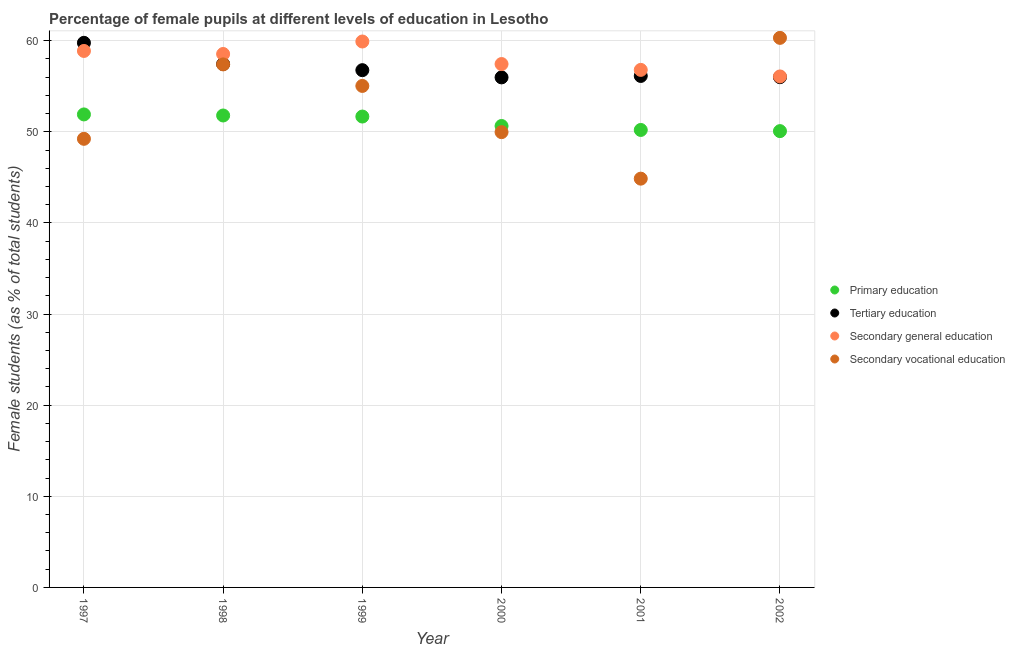How many different coloured dotlines are there?
Provide a short and direct response. 4. Is the number of dotlines equal to the number of legend labels?
Make the answer very short. Yes. What is the percentage of female students in secondary education in 1998?
Give a very brief answer. 58.54. Across all years, what is the maximum percentage of female students in secondary vocational education?
Offer a terse response. 60.31. Across all years, what is the minimum percentage of female students in secondary vocational education?
Your response must be concise. 44.86. In which year was the percentage of female students in secondary vocational education maximum?
Offer a terse response. 2002. What is the total percentage of female students in secondary education in the graph?
Your answer should be very brief. 347.62. What is the difference between the percentage of female students in primary education in 1997 and that in 2002?
Ensure brevity in your answer.  1.83. What is the difference between the percentage of female students in secondary education in 1999 and the percentage of female students in secondary vocational education in 2000?
Provide a short and direct response. 9.95. What is the average percentage of female students in secondary education per year?
Make the answer very short. 57.94. In the year 1998, what is the difference between the percentage of female students in tertiary education and percentage of female students in secondary vocational education?
Give a very brief answer. 0.04. In how many years, is the percentage of female students in secondary education greater than 34 %?
Keep it short and to the point. 6. What is the ratio of the percentage of female students in secondary education in 1999 to that in 2002?
Offer a terse response. 1.07. Is the percentage of female students in secondary vocational education in 1997 less than that in 1998?
Provide a succinct answer. Yes. Is the difference between the percentage of female students in secondary vocational education in 1997 and 2000 greater than the difference between the percentage of female students in secondary education in 1997 and 2000?
Ensure brevity in your answer.  No. What is the difference between the highest and the second highest percentage of female students in secondary education?
Provide a short and direct response. 1.04. What is the difference between the highest and the lowest percentage of female students in secondary education?
Your answer should be compact. 3.83. In how many years, is the percentage of female students in tertiary education greater than the average percentage of female students in tertiary education taken over all years?
Ensure brevity in your answer.  2. Is the sum of the percentage of female students in secondary education in 1997 and 2001 greater than the maximum percentage of female students in primary education across all years?
Ensure brevity in your answer.  Yes. Does the percentage of female students in tertiary education monotonically increase over the years?
Keep it short and to the point. No. Is the percentage of female students in secondary vocational education strictly greater than the percentage of female students in tertiary education over the years?
Offer a very short reply. No. Is the percentage of female students in secondary vocational education strictly less than the percentage of female students in tertiary education over the years?
Provide a succinct answer. No. What is the difference between two consecutive major ticks on the Y-axis?
Your answer should be very brief. 10. Are the values on the major ticks of Y-axis written in scientific E-notation?
Your answer should be very brief. No. Does the graph contain grids?
Keep it short and to the point. Yes. How many legend labels are there?
Provide a short and direct response. 4. How are the legend labels stacked?
Your answer should be very brief. Vertical. What is the title of the graph?
Make the answer very short. Percentage of female pupils at different levels of education in Lesotho. Does "Norway" appear as one of the legend labels in the graph?
Your answer should be very brief. No. What is the label or title of the X-axis?
Provide a succinct answer. Year. What is the label or title of the Y-axis?
Offer a very short reply. Female students (as % of total students). What is the Female students (as % of total students) in Primary education in 1997?
Provide a short and direct response. 51.91. What is the Female students (as % of total students) of Tertiary education in 1997?
Give a very brief answer. 59.76. What is the Female students (as % of total students) of Secondary general education in 1997?
Make the answer very short. 58.87. What is the Female students (as % of total students) in Secondary vocational education in 1997?
Offer a terse response. 49.23. What is the Female students (as % of total students) in Primary education in 1998?
Make the answer very short. 51.79. What is the Female students (as % of total students) in Tertiary education in 1998?
Your answer should be very brief. 57.43. What is the Female students (as % of total students) of Secondary general education in 1998?
Keep it short and to the point. 58.54. What is the Female students (as % of total students) of Secondary vocational education in 1998?
Your answer should be compact. 57.4. What is the Female students (as % of total students) of Primary education in 1999?
Make the answer very short. 51.67. What is the Female students (as % of total students) in Tertiary education in 1999?
Provide a short and direct response. 56.76. What is the Female students (as % of total students) of Secondary general education in 1999?
Offer a terse response. 59.91. What is the Female students (as % of total students) of Secondary vocational education in 1999?
Make the answer very short. 55.03. What is the Female students (as % of total students) of Primary education in 2000?
Give a very brief answer. 50.64. What is the Female students (as % of total students) of Tertiary education in 2000?
Your response must be concise. 55.97. What is the Female students (as % of total students) of Secondary general education in 2000?
Provide a succinct answer. 57.43. What is the Female students (as % of total students) of Secondary vocational education in 2000?
Your response must be concise. 49.96. What is the Female students (as % of total students) in Primary education in 2001?
Give a very brief answer. 50.2. What is the Female students (as % of total students) of Tertiary education in 2001?
Your answer should be very brief. 56.13. What is the Female students (as % of total students) of Secondary general education in 2001?
Offer a very short reply. 56.79. What is the Female students (as % of total students) in Secondary vocational education in 2001?
Give a very brief answer. 44.86. What is the Female students (as % of total students) in Primary education in 2002?
Provide a short and direct response. 50.07. What is the Female students (as % of total students) in Tertiary education in 2002?
Offer a terse response. 55.99. What is the Female students (as % of total students) of Secondary general education in 2002?
Offer a very short reply. 56.07. What is the Female students (as % of total students) of Secondary vocational education in 2002?
Make the answer very short. 60.31. Across all years, what is the maximum Female students (as % of total students) in Primary education?
Your answer should be very brief. 51.91. Across all years, what is the maximum Female students (as % of total students) in Tertiary education?
Keep it short and to the point. 59.76. Across all years, what is the maximum Female students (as % of total students) of Secondary general education?
Your answer should be compact. 59.91. Across all years, what is the maximum Female students (as % of total students) of Secondary vocational education?
Give a very brief answer. 60.31. Across all years, what is the minimum Female students (as % of total students) of Primary education?
Your response must be concise. 50.07. Across all years, what is the minimum Female students (as % of total students) of Tertiary education?
Offer a terse response. 55.97. Across all years, what is the minimum Female students (as % of total students) of Secondary general education?
Ensure brevity in your answer.  56.07. Across all years, what is the minimum Female students (as % of total students) of Secondary vocational education?
Offer a terse response. 44.86. What is the total Female students (as % of total students) of Primary education in the graph?
Provide a succinct answer. 306.28. What is the total Female students (as % of total students) of Tertiary education in the graph?
Your answer should be compact. 342.06. What is the total Female students (as % of total students) in Secondary general education in the graph?
Offer a very short reply. 347.62. What is the total Female students (as % of total students) of Secondary vocational education in the graph?
Offer a very short reply. 316.79. What is the difference between the Female students (as % of total students) in Primary education in 1997 and that in 1998?
Provide a succinct answer. 0.12. What is the difference between the Female students (as % of total students) of Tertiary education in 1997 and that in 1998?
Ensure brevity in your answer.  2.33. What is the difference between the Female students (as % of total students) in Secondary general education in 1997 and that in 1998?
Keep it short and to the point. 0.33. What is the difference between the Female students (as % of total students) in Secondary vocational education in 1997 and that in 1998?
Ensure brevity in your answer.  -8.17. What is the difference between the Female students (as % of total students) of Primary education in 1997 and that in 1999?
Ensure brevity in your answer.  0.23. What is the difference between the Female students (as % of total students) of Tertiary education in 1997 and that in 1999?
Ensure brevity in your answer.  3. What is the difference between the Female students (as % of total students) of Secondary general education in 1997 and that in 1999?
Your answer should be compact. -1.04. What is the difference between the Female students (as % of total students) of Secondary vocational education in 1997 and that in 1999?
Keep it short and to the point. -5.8. What is the difference between the Female students (as % of total students) in Primary education in 1997 and that in 2000?
Provide a short and direct response. 1.27. What is the difference between the Female students (as % of total students) of Tertiary education in 1997 and that in 2000?
Provide a short and direct response. 3.79. What is the difference between the Female students (as % of total students) in Secondary general education in 1997 and that in 2000?
Offer a very short reply. 1.44. What is the difference between the Female students (as % of total students) in Secondary vocational education in 1997 and that in 2000?
Ensure brevity in your answer.  -0.73. What is the difference between the Female students (as % of total students) of Primary education in 1997 and that in 2001?
Provide a short and direct response. 1.7. What is the difference between the Female students (as % of total students) of Tertiary education in 1997 and that in 2001?
Give a very brief answer. 3.64. What is the difference between the Female students (as % of total students) in Secondary general education in 1997 and that in 2001?
Your answer should be very brief. 2.08. What is the difference between the Female students (as % of total students) of Secondary vocational education in 1997 and that in 2001?
Provide a succinct answer. 4.37. What is the difference between the Female students (as % of total students) in Primary education in 1997 and that in 2002?
Give a very brief answer. 1.83. What is the difference between the Female students (as % of total students) of Tertiary education in 1997 and that in 2002?
Offer a terse response. 3.77. What is the difference between the Female students (as % of total students) of Secondary general education in 1997 and that in 2002?
Provide a succinct answer. 2.8. What is the difference between the Female students (as % of total students) of Secondary vocational education in 1997 and that in 2002?
Provide a short and direct response. -11.08. What is the difference between the Female students (as % of total students) of Primary education in 1998 and that in 1999?
Provide a succinct answer. 0.11. What is the difference between the Female students (as % of total students) in Tertiary education in 1998 and that in 1999?
Your answer should be compact. 0.67. What is the difference between the Female students (as % of total students) in Secondary general education in 1998 and that in 1999?
Your response must be concise. -1.37. What is the difference between the Female students (as % of total students) in Secondary vocational education in 1998 and that in 1999?
Your response must be concise. 2.36. What is the difference between the Female students (as % of total students) in Primary education in 1998 and that in 2000?
Keep it short and to the point. 1.15. What is the difference between the Female students (as % of total students) in Tertiary education in 1998 and that in 2000?
Your answer should be very brief. 1.46. What is the difference between the Female students (as % of total students) of Secondary general education in 1998 and that in 2000?
Offer a terse response. 1.1. What is the difference between the Female students (as % of total students) of Secondary vocational education in 1998 and that in 2000?
Offer a very short reply. 7.43. What is the difference between the Female students (as % of total students) of Primary education in 1998 and that in 2001?
Provide a succinct answer. 1.59. What is the difference between the Female students (as % of total students) in Tertiary education in 1998 and that in 2001?
Give a very brief answer. 1.31. What is the difference between the Female students (as % of total students) in Secondary general education in 1998 and that in 2001?
Provide a short and direct response. 1.75. What is the difference between the Female students (as % of total students) in Secondary vocational education in 1998 and that in 2001?
Offer a terse response. 12.54. What is the difference between the Female students (as % of total students) in Primary education in 1998 and that in 2002?
Your response must be concise. 1.72. What is the difference between the Female students (as % of total students) in Tertiary education in 1998 and that in 2002?
Provide a succinct answer. 1.44. What is the difference between the Female students (as % of total students) in Secondary general education in 1998 and that in 2002?
Your answer should be very brief. 2.46. What is the difference between the Female students (as % of total students) in Secondary vocational education in 1998 and that in 2002?
Your response must be concise. -2.91. What is the difference between the Female students (as % of total students) of Primary education in 1999 and that in 2000?
Provide a succinct answer. 1.04. What is the difference between the Female students (as % of total students) of Tertiary education in 1999 and that in 2000?
Your answer should be compact. 0.79. What is the difference between the Female students (as % of total students) of Secondary general education in 1999 and that in 2000?
Offer a very short reply. 2.47. What is the difference between the Female students (as % of total students) of Secondary vocational education in 1999 and that in 2000?
Ensure brevity in your answer.  5.07. What is the difference between the Female students (as % of total students) of Primary education in 1999 and that in 2001?
Keep it short and to the point. 1.47. What is the difference between the Female students (as % of total students) in Tertiary education in 1999 and that in 2001?
Your response must be concise. 0.63. What is the difference between the Female students (as % of total students) in Secondary general education in 1999 and that in 2001?
Make the answer very short. 3.11. What is the difference between the Female students (as % of total students) in Secondary vocational education in 1999 and that in 2001?
Your answer should be very brief. 10.18. What is the difference between the Female students (as % of total students) in Primary education in 1999 and that in 2002?
Provide a short and direct response. 1.6. What is the difference between the Female students (as % of total students) in Tertiary education in 1999 and that in 2002?
Ensure brevity in your answer.  0.77. What is the difference between the Female students (as % of total students) of Secondary general education in 1999 and that in 2002?
Provide a succinct answer. 3.83. What is the difference between the Female students (as % of total students) of Secondary vocational education in 1999 and that in 2002?
Offer a terse response. -5.27. What is the difference between the Female students (as % of total students) in Primary education in 2000 and that in 2001?
Provide a succinct answer. 0.43. What is the difference between the Female students (as % of total students) of Tertiary education in 2000 and that in 2001?
Keep it short and to the point. -0.16. What is the difference between the Female students (as % of total students) of Secondary general education in 2000 and that in 2001?
Ensure brevity in your answer.  0.64. What is the difference between the Female students (as % of total students) in Secondary vocational education in 2000 and that in 2001?
Make the answer very short. 5.1. What is the difference between the Female students (as % of total students) of Primary education in 2000 and that in 2002?
Keep it short and to the point. 0.56. What is the difference between the Female students (as % of total students) in Tertiary education in 2000 and that in 2002?
Offer a very short reply. -0.02. What is the difference between the Female students (as % of total students) of Secondary general education in 2000 and that in 2002?
Offer a very short reply. 1.36. What is the difference between the Female students (as % of total students) of Secondary vocational education in 2000 and that in 2002?
Provide a succinct answer. -10.35. What is the difference between the Female students (as % of total students) in Primary education in 2001 and that in 2002?
Keep it short and to the point. 0.13. What is the difference between the Female students (as % of total students) in Tertiary education in 2001 and that in 2002?
Your answer should be compact. 0.13. What is the difference between the Female students (as % of total students) of Secondary general education in 2001 and that in 2002?
Your answer should be very brief. 0.72. What is the difference between the Female students (as % of total students) in Secondary vocational education in 2001 and that in 2002?
Offer a very short reply. -15.45. What is the difference between the Female students (as % of total students) of Primary education in 1997 and the Female students (as % of total students) of Tertiary education in 1998?
Provide a succinct answer. -5.53. What is the difference between the Female students (as % of total students) of Primary education in 1997 and the Female students (as % of total students) of Secondary general education in 1998?
Ensure brevity in your answer.  -6.63. What is the difference between the Female students (as % of total students) in Primary education in 1997 and the Female students (as % of total students) in Secondary vocational education in 1998?
Offer a very short reply. -5.49. What is the difference between the Female students (as % of total students) of Tertiary education in 1997 and the Female students (as % of total students) of Secondary general education in 1998?
Ensure brevity in your answer.  1.23. What is the difference between the Female students (as % of total students) of Tertiary education in 1997 and the Female students (as % of total students) of Secondary vocational education in 1998?
Provide a succinct answer. 2.37. What is the difference between the Female students (as % of total students) of Secondary general education in 1997 and the Female students (as % of total students) of Secondary vocational education in 1998?
Offer a terse response. 1.48. What is the difference between the Female students (as % of total students) in Primary education in 1997 and the Female students (as % of total students) in Tertiary education in 1999?
Make the answer very short. -4.86. What is the difference between the Female students (as % of total students) of Primary education in 1997 and the Female students (as % of total students) of Secondary general education in 1999?
Your answer should be compact. -8. What is the difference between the Female students (as % of total students) in Primary education in 1997 and the Female students (as % of total students) in Secondary vocational education in 1999?
Offer a very short reply. -3.13. What is the difference between the Female students (as % of total students) of Tertiary education in 1997 and the Female students (as % of total students) of Secondary general education in 1999?
Ensure brevity in your answer.  -0.14. What is the difference between the Female students (as % of total students) in Tertiary education in 1997 and the Female students (as % of total students) in Secondary vocational education in 1999?
Provide a succinct answer. 4.73. What is the difference between the Female students (as % of total students) of Secondary general education in 1997 and the Female students (as % of total students) of Secondary vocational education in 1999?
Offer a terse response. 3.84. What is the difference between the Female students (as % of total students) in Primary education in 1997 and the Female students (as % of total students) in Tertiary education in 2000?
Your answer should be compact. -4.06. What is the difference between the Female students (as % of total students) of Primary education in 1997 and the Female students (as % of total students) of Secondary general education in 2000?
Your answer should be compact. -5.53. What is the difference between the Female students (as % of total students) of Primary education in 1997 and the Female students (as % of total students) of Secondary vocational education in 2000?
Your response must be concise. 1.94. What is the difference between the Female students (as % of total students) in Tertiary education in 1997 and the Female students (as % of total students) in Secondary general education in 2000?
Provide a succinct answer. 2.33. What is the difference between the Female students (as % of total students) of Tertiary education in 1997 and the Female students (as % of total students) of Secondary vocational education in 2000?
Keep it short and to the point. 9.8. What is the difference between the Female students (as % of total students) of Secondary general education in 1997 and the Female students (as % of total students) of Secondary vocational education in 2000?
Offer a terse response. 8.91. What is the difference between the Female students (as % of total students) of Primary education in 1997 and the Female students (as % of total students) of Tertiary education in 2001?
Make the answer very short. -4.22. What is the difference between the Female students (as % of total students) in Primary education in 1997 and the Female students (as % of total students) in Secondary general education in 2001?
Make the answer very short. -4.89. What is the difference between the Female students (as % of total students) of Primary education in 1997 and the Female students (as % of total students) of Secondary vocational education in 2001?
Keep it short and to the point. 7.05. What is the difference between the Female students (as % of total students) in Tertiary education in 1997 and the Female students (as % of total students) in Secondary general education in 2001?
Give a very brief answer. 2.97. What is the difference between the Female students (as % of total students) of Tertiary education in 1997 and the Female students (as % of total students) of Secondary vocational education in 2001?
Your response must be concise. 14.91. What is the difference between the Female students (as % of total students) of Secondary general education in 1997 and the Female students (as % of total students) of Secondary vocational education in 2001?
Your answer should be very brief. 14.01. What is the difference between the Female students (as % of total students) in Primary education in 1997 and the Female students (as % of total students) in Tertiary education in 2002?
Keep it short and to the point. -4.09. What is the difference between the Female students (as % of total students) in Primary education in 1997 and the Female students (as % of total students) in Secondary general education in 2002?
Your response must be concise. -4.17. What is the difference between the Female students (as % of total students) of Primary education in 1997 and the Female students (as % of total students) of Secondary vocational education in 2002?
Make the answer very short. -8.4. What is the difference between the Female students (as % of total students) of Tertiary education in 1997 and the Female students (as % of total students) of Secondary general education in 2002?
Give a very brief answer. 3.69. What is the difference between the Female students (as % of total students) in Tertiary education in 1997 and the Female students (as % of total students) in Secondary vocational education in 2002?
Give a very brief answer. -0.54. What is the difference between the Female students (as % of total students) in Secondary general education in 1997 and the Female students (as % of total students) in Secondary vocational education in 2002?
Offer a very short reply. -1.44. What is the difference between the Female students (as % of total students) in Primary education in 1998 and the Female students (as % of total students) in Tertiary education in 1999?
Provide a succinct answer. -4.97. What is the difference between the Female students (as % of total students) of Primary education in 1998 and the Female students (as % of total students) of Secondary general education in 1999?
Provide a succinct answer. -8.12. What is the difference between the Female students (as % of total students) in Primary education in 1998 and the Female students (as % of total students) in Secondary vocational education in 1999?
Offer a terse response. -3.24. What is the difference between the Female students (as % of total students) in Tertiary education in 1998 and the Female students (as % of total students) in Secondary general education in 1999?
Make the answer very short. -2.47. What is the difference between the Female students (as % of total students) in Tertiary education in 1998 and the Female students (as % of total students) in Secondary vocational education in 1999?
Your answer should be very brief. 2.4. What is the difference between the Female students (as % of total students) of Secondary general education in 1998 and the Female students (as % of total students) of Secondary vocational education in 1999?
Give a very brief answer. 3.51. What is the difference between the Female students (as % of total students) of Primary education in 1998 and the Female students (as % of total students) of Tertiary education in 2000?
Make the answer very short. -4.18. What is the difference between the Female students (as % of total students) in Primary education in 1998 and the Female students (as % of total students) in Secondary general education in 2000?
Make the answer very short. -5.65. What is the difference between the Female students (as % of total students) in Primary education in 1998 and the Female students (as % of total students) in Secondary vocational education in 2000?
Keep it short and to the point. 1.83. What is the difference between the Female students (as % of total students) in Tertiary education in 1998 and the Female students (as % of total students) in Secondary general education in 2000?
Ensure brevity in your answer.  -0. What is the difference between the Female students (as % of total students) in Tertiary education in 1998 and the Female students (as % of total students) in Secondary vocational education in 2000?
Make the answer very short. 7.47. What is the difference between the Female students (as % of total students) of Secondary general education in 1998 and the Female students (as % of total students) of Secondary vocational education in 2000?
Provide a short and direct response. 8.58. What is the difference between the Female students (as % of total students) in Primary education in 1998 and the Female students (as % of total students) in Tertiary education in 2001?
Offer a very short reply. -4.34. What is the difference between the Female students (as % of total students) in Primary education in 1998 and the Female students (as % of total students) in Secondary general education in 2001?
Your response must be concise. -5. What is the difference between the Female students (as % of total students) of Primary education in 1998 and the Female students (as % of total students) of Secondary vocational education in 2001?
Give a very brief answer. 6.93. What is the difference between the Female students (as % of total students) of Tertiary education in 1998 and the Female students (as % of total students) of Secondary general education in 2001?
Give a very brief answer. 0.64. What is the difference between the Female students (as % of total students) in Tertiary education in 1998 and the Female students (as % of total students) in Secondary vocational education in 2001?
Offer a very short reply. 12.58. What is the difference between the Female students (as % of total students) in Secondary general education in 1998 and the Female students (as % of total students) in Secondary vocational education in 2001?
Provide a succinct answer. 13.68. What is the difference between the Female students (as % of total students) in Primary education in 1998 and the Female students (as % of total students) in Tertiary education in 2002?
Offer a very short reply. -4.21. What is the difference between the Female students (as % of total students) in Primary education in 1998 and the Female students (as % of total students) in Secondary general education in 2002?
Your response must be concise. -4.29. What is the difference between the Female students (as % of total students) in Primary education in 1998 and the Female students (as % of total students) in Secondary vocational education in 2002?
Offer a terse response. -8.52. What is the difference between the Female students (as % of total students) of Tertiary education in 1998 and the Female students (as % of total students) of Secondary general education in 2002?
Your answer should be very brief. 1.36. What is the difference between the Female students (as % of total students) in Tertiary education in 1998 and the Female students (as % of total students) in Secondary vocational education in 2002?
Keep it short and to the point. -2.87. What is the difference between the Female students (as % of total students) of Secondary general education in 1998 and the Female students (as % of total students) of Secondary vocational education in 2002?
Ensure brevity in your answer.  -1.77. What is the difference between the Female students (as % of total students) of Primary education in 1999 and the Female students (as % of total students) of Tertiary education in 2000?
Make the answer very short. -4.3. What is the difference between the Female students (as % of total students) in Primary education in 1999 and the Female students (as % of total students) in Secondary general education in 2000?
Make the answer very short. -5.76. What is the difference between the Female students (as % of total students) in Primary education in 1999 and the Female students (as % of total students) in Secondary vocational education in 2000?
Offer a very short reply. 1.71. What is the difference between the Female students (as % of total students) in Tertiary education in 1999 and the Female students (as % of total students) in Secondary general education in 2000?
Your response must be concise. -0.67. What is the difference between the Female students (as % of total students) in Tertiary education in 1999 and the Female students (as % of total students) in Secondary vocational education in 2000?
Ensure brevity in your answer.  6.8. What is the difference between the Female students (as % of total students) in Secondary general education in 1999 and the Female students (as % of total students) in Secondary vocational education in 2000?
Give a very brief answer. 9.95. What is the difference between the Female students (as % of total students) of Primary education in 1999 and the Female students (as % of total students) of Tertiary education in 2001?
Offer a terse response. -4.45. What is the difference between the Female students (as % of total students) of Primary education in 1999 and the Female students (as % of total students) of Secondary general education in 2001?
Your response must be concise. -5.12. What is the difference between the Female students (as % of total students) of Primary education in 1999 and the Female students (as % of total students) of Secondary vocational education in 2001?
Provide a succinct answer. 6.82. What is the difference between the Female students (as % of total students) in Tertiary education in 1999 and the Female students (as % of total students) in Secondary general education in 2001?
Ensure brevity in your answer.  -0.03. What is the difference between the Female students (as % of total students) in Tertiary education in 1999 and the Female students (as % of total students) in Secondary vocational education in 2001?
Your answer should be compact. 11.9. What is the difference between the Female students (as % of total students) of Secondary general education in 1999 and the Female students (as % of total students) of Secondary vocational education in 2001?
Provide a short and direct response. 15.05. What is the difference between the Female students (as % of total students) in Primary education in 1999 and the Female students (as % of total students) in Tertiary education in 2002?
Provide a short and direct response. -4.32. What is the difference between the Female students (as % of total students) of Primary education in 1999 and the Female students (as % of total students) of Secondary general education in 2002?
Ensure brevity in your answer.  -4.4. What is the difference between the Female students (as % of total students) in Primary education in 1999 and the Female students (as % of total students) in Secondary vocational education in 2002?
Provide a succinct answer. -8.63. What is the difference between the Female students (as % of total students) of Tertiary education in 1999 and the Female students (as % of total students) of Secondary general education in 2002?
Your response must be concise. 0.69. What is the difference between the Female students (as % of total students) of Tertiary education in 1999 and the Female students (as % of total students) of Secondary vocational education in 2002?
Ensure brevity in your answer.  -3.55. What is the difference between the Female students (as % of total students) in Secondary general education in 1999 and the Female students (as % of total students) in Secondary vocational education in 2002?
Offer a very short reply. -0.4. What is the difference between the Female students (as % of total students) in Primary education in 2000 and the Female students (as % of total students) in Tertiary education in 2001?
Offer a very short reply. -5.49. What is the difference between the Female students (as % of total students) of Primary education in 2000 and the Female students (as % of total students) of Secondary general education in 2001?
Your answer should be compact. -6.16. What is the difference between the Female students (as % of total students) in Primary education in 2000 and the Female students (as % of total students) in Secondary vocational education in 2001?
Provide a succinct answer. 5.78. What is the difference between the Female students (as % of total students) of Tertiary education in 2000 and the Female students (as % of total students) of Secondary general education in 2001?
Make the answer very short. -0.82. What is the difference between the Female students (as % of total students) in Tertiary education in 2000 and the Female students (as % of total students) in Secondary vocational education in 2001?
Give a very brief answer. 11.11. What is the difference between the Female students (as % of total students) in Secondary general education in 2000 and the Female students (as % of total students) in Secondary vocational education in 2001?
Give a very brief answer. 12.58. What is the difference between the Female students (as % of total students) in Primary education in 2000 and the Female students (as % of total students) in Tertiary education in 2002?
Your answer should be compact. -5.36. What is the difference between the Female students (as % of total students) in Primary education in 2000 and the Female students (as % of total students) in Secondary general education in 2002?
Make the answer very short. -5.44. What is the difference between the Female students (as % of total students) of Primary education in 2000 and the Female students (as % of total students) of Secondary vocational education in 2002?
Provide a short and direct response. -9.67. What is the difference between the Female students (as % of total students) in Tertiary education in 2000 and the Female students (as % of total students) in Secondary general education in 2002?
Your answer should be very brief. -0.1. What is the difference between the Female students (as % of total students) of Tertiary education in 2000 and the Female students (as % of total students) of Secondary vocational education in 2002?
Your response must be concise. -4.34. What is the difference between the Female students (as % of total students) of Secondary general education in 2000 and the Female students (as % of total students) of Secondary vocational education in 2002?
Your answer should be compact. -2.87. What is the difference between the Female students (as % of total students) of Primary education in 2001 and the Female students (as % of total students) of Tertiary education in 2002?
Make the answer very short. -5.79. What is the difference between the Female students (as % of total students) of Primary education in 2001 and the Female students (as % of total students) of Secondary general education in 2002?
Offer a terse response. -5.87. What is the difference between the Female students (as % of total students) of Primary education in 2001 and the Female students (as % of total students) of Secondary vocational education in 2002?
Your answer should be very brief. -10.11. What is the difference between the Female students (as % of total students) in Tertiary education in 2001 and the Female students (as % of total students) in Secondary general education in 2002?
Make the answer very short. 0.05. What is the difference between the Female students (as % of total students) in Tertiary education in 2001 and the Female students (as % of total students) in Secondary vocational education in 2002?
Provide a succinct answer. -4.18. What is the difference between the Female students (as % of total students) of Secondary general education in 2001 and the Female students (as % of total students) of Secondary vocational education in 2002?
Your answer should be very brief. -3.51. What is the average Female students (as % of total students) in Primary education per year?
Provide a short and direct response. 51.05. What is the average Female students (as % of total students) of Tertiary education per year?
Provide a short and direct response. 57.01. What is the average Female students (as % of total students) in Secondary general education per year?
Ensure brevity in your answer.  57.94. What is the average Female students (as % of total students) in Secondary vocational education per year?
Keep it short and to the point. 52.8. In the year 1997, what is the difference between the Female students (as % of total students) of Primary education and Female students (as % of total students) of Tertiary education?
Your response must be concise. -7.86. In the year 1997, what is the difference between the Female students (as % of total students) of Primary education and Female students (as % of total students) of Secondary general education?
Give a very brief answer. -6.97. In the year 1997, what is the difference between the Female students (as % of total students) of Primary education and Female students (as % of total students) of Secondary vocational education?
Your answer should be very brief. 2.68. In the year 1997, what is the difference between the Female students (as % of total students) of Tertiary education and Female students (as % of total students) of Secondary general education?
Provide a short and direct response. 0.89. In the year 1997, what is the difference between the Female students (as % of total students) of Tertiary education and Female students (as % of total students) of Secondary vocational education?
Your answer should be compact. 10.54. In the year 1997, what is the difference between the Female students (as % of total students) of Secondary general education and Female students (as % of total students) of Secondary vocational education?
Your response must be concise. 9.64. In the year 1998, what is the difference between the Female students (as % of total students) of Primary education and Female students (as % of total students) of Tertiary education?
Offer a very short reply. -5.64. In the year 1998, what is the difference between the Female students (as % of total students) of Primary education and Female students (as % of total students) of Secondary general education?
Keep it short and to the point. -6.75. In the year 1998, what is the difference between the Female students (as % of total students) in Primary education and Female students (as % of total students) in Secondary vocational education?
Offer a very short reply. -5.61. In the year 1998, what is the difference between the Female students (as % of total students) of Tertiary education and Female students (as % of total students) of Secondary general education?
Ensure brevity in your answer.  -1.11. In the year 1998, what is the difference between the Female students (as % of total students) of Tertiary education and Female students (as % of total students) of Secondary vocational education?
Keep it short and to the point. 0.04. In the year 1998, what is the difference between the Female students (as % of total students) in Secondary general education and Female students (as % of total students) in Secondary vocational education?
Provide a short and direct response. 1.14. In the year 1999, what is the difference between the Female students (as % of total students) in Primary education and Female students (as % of total students) in Tertiary education?
Keep it short and to the point. -5.09. In the year 1999, what is the difference between the Female students (as % of total students) in Primary education and Female students (as % of total students) in Secondary general education?
Provide a short and direct response. -8.23. In the year 1999, what is the difference between the Female students (as % of total students) of Primary education and Female students (as % of total students) of Secondary vocational education?
Give a very brief answer. -3.36. In the year 1999, what is the difference between the Female students (as % of total students) of Tertiary education and Female students (as % of total students) of Secondary general education?
Your response must be concise. -3.15. In the year 1999, what is the difference between the Female students (as % of total students) in Tertiary education and Female students (as % of total students) in Secondary vocational education?
Your answer should be compact. 1.73. In the year 1999, what is the difference between the Female students (as % of total students) of Secondary general education and Female students (as % of total students) of Secondary vocational education?
Offer a terse response. 4.87. In the year 2000, what is the difference between the Female students (as % of total students) in Primary education and Female students (as % of total students) in Tertiary education?
Keep it short and to the point. -5.33. In the year 2000, what is the difference between the Female students (as % of total students) of Primary education and Female students (as % of total students) of Secondary general education?
Offer a terse response. -6.8. In the year 2000, what is the difference between the Female students (as % of total students) in Primary education and Female students (as % of total students) in Secondary vocational education?
Your answer should be very brief. 0.67. In the year 2000, what is the difference between the Female students (as % of total students) of Tertiary education and Female students (as % of total students) of Secondary general education?
Provide a succinct answer. -1.46. In the year 2000, what is the difference between the Female students (as % of total students) in Tertiary education and Female students (as % of total students) in Secondary vocational education?
Keep it short and to the point. 6.01. In the year 2000, what is the difference between the Female students (as % of total students) in Secondary general education and Female students (as % of total students) in Secondary vocational education?
Your answer should be compact. 7.47. In the year 2001, what is the difference between the Female students (as % of total students) of Primary education and Female students (as % of total students) of Tertiary education?
Your answer should be very brief. -5.93. In the year 2001, what is the difference between the Female students (as % of total students) of Primary education and Female students (as % of total students) of Secondary general education?
Provide a succinct answer. -6.59. In the year 2001, what is the difference between the Female students (as % of total students) in Primary education and Female students (as % of total students) in Secondary vocational education?
Give a very brief answer. 5.34. In the year 2001, what is the difference between the Female students (as % of total students) in Tertiary education and Female students (as % of total students) in Secondary general education?
Make the answer very short. -0.67. In the year 2001, what is the difference between the Female students (as % of total students) in Tertiary education and Female students (as % of total students) in Secondary vocational education?
Offer a very short reply. 11.27. In the year 2001, what is the difference between the Female students (as % of total students) of Secondary general education and Female students (as % of total students) of Secondary vocational education?
Provide a short and direct response. 11.94. In the year 2002, what is the difference between the Female students (as % of total students) of Primary education and Female students (as % of total students) of Tertiary education?
Ensure brevity in your answer.  -5.92. In the year 2002, what is the difference between the Female students (as % of total students) in Primary education and Female students (as % of total students) in Secondary general education?
Give a very brief answer. -6. In the year 2002, what is the difference between the Female students (as % of total students) in Primary education and Female students (as % of total students) in Secondary vocational education?
Offer a very short reply. -10.23. In the year 2002, what is the difference between the Female students (as % of total students) in Tertiary education and Female students (as % of total students) in Secondary general education?
Make the answer very short. -0.08. In the year 2002, what is the difference between the Female students (as % of total students) of Tertiary education and Female students (as % of total students) of Secondary vocational education?
Your answer should be compact. -4.31. In the year 2002, what is the difference between the Female students (as % of total students) in Secondary general education and Female students (as % of total students) in Secondary vocational education?
Ensure brevity in your answer.  -4.23. What is the ratio of the Female students (as % of total students) of Tertiary education in 1997 to that in 1998?
Your answer should be compact. 1.04. What is the ratio of the Female students (as % of total students) of Secondary vocational education in 1997 to that in 1998?
Your answer should be very brief. 0.86. What is the ratio of the Female students (as % of total students) of Primary education in 1997 to that in 1999?
Give a very brief answer. 1. What is the ratio of the Female students (as % of total students) in Tertiary education in 1997 to that in 1999?
Give a very brief answer. 1.05. What is the ratio of the Female students (as % of total students) in Secondary general education in 1997 to that in 1999?
Keep it short and to the point. 0.98. What is the ratio of the Female students (as % of total students) of Secondary vocational education in 1997 to that in 1999?
Your response must be concise. 0.89. What is the ratio of the Female students (as % of total students) in Primary education in 1997 to that in 2000?
Give a very brief answer. 1.03. What is the ratio of the Female students (as % of total students) in Tertiary education in 1997 to that in 2000?
Offer a terse response. 1.07. What is the ratio of the Female students (as % of total students) of Secondary general education in 1997 to that in 2000?
Provide a succinct answer. 1.02. What is the ratio of the Female students (as % of total students) of Primary education in 1997 to that in 2001?
Provide a succinct answer. 1.03. What is the ratio of the Female students (as % of total students) in Tertiary education in 1997 to that in 2001?
Give a very brief answer. 1.06. What is the ratio of the Female students (as % of total students) of Secondary general education in 1997 to that in 2001?
Provide a succinct answer. 1.04. What is the ratio of the Female students (as % of total students) of Secondary vocational education in 1997 to that in 2001?
Your answer should be very brief. 1.1. What is the ratio of the Female students (as % of total students) in Primary education in 1997 to that in 2002?
Your answer should be compact. 1.04. What is the ratio of the Female students (as % of total students) of Tertiary education in 1997 to that in 2002?
Provide a short and direct response. 1.07. What is the ratio of the Female students (as % of total students) of Secondary general education in 1997 to that in 2002?
Make the answer very short. 1.05. What is the ratio of the Female students (as % of total students) in Secondary vocational education in 1997 to that in 2002?
Offer a very short reply. 0.82. What is the ratio of the Female students (as % of total students) of Primary education in 1998 to that in 1999?
Your response must be concise. 1. What is the ratio of the Female students (as % of total students) of Tertiary education in 1998 to that in 1999?
Give a very brief answer. 1.01. What is the ratio of the Female students (as % of total students) of Secondary general education in 1998 to that in 1999?
Make the answer very short. 0.98. What is the ratio of the Female students (as % of total students) of Secondary vocational education in 1998 to that in 1999?
Your answer should be very brief. 1.04. What is the ratio of the Female students (as % of total students) in Primary education in 1998 to that in 2000?
Give a very brief answer. 1.02. What is the ratio of the Female students (as % of total students) of Tertiary education in 1998 to that in 2000?
Offer a terse response. 1.03. What is the ratio of the Female students (as % of total students) in Secondary general education in 1998 to that in 2000?
Offer a very short reply. 1.02. What is the ratio of the Female students (as % of total students) in Secondary vocational education in 1998 to that in 2000?
Your response must be concise. 1.15. What is the ratio of the Female students (as % of total students) in Primary education in 1998 to that in 2001?
Your answer should be very brief. 1.03. What is the ratio of the Female students (as % of total students) in Tertiary education in 1998 to that in 2001?
Your response must be concise. 1.02. What is the ratio of the Female students (as % of total students) in Secondary general education in 1998 to that in 2001?
Make the answer very short. 1.03. What is the ratio of the Female students (as % of total students) in Secondary vocational education in 1998 to that in 2001?
Keep it short and to the point. 1.28. What is the ratio of the Female students (as % of total students) in Primary education in 1998 to that in 2002?
Provide a short and direct response. 1.03. What is the ratio of the Female students (as % of total students) in Tertiary education in 1998 to that in 2002?
Your response must be concise. 1.03. What is the ratio of the Female students (as % of total students) in Secondary general education in 1998 to that in 2002?
Offer a very short reply. 1.04. What is the ratio of the Female students (as % of total students) of Secondary vocational education in 1998 to that in 2002?
Provide a short and direct response. 0.95. What is the ratio of the Female students (as % of total students) in Primary education in 1999 to that in 2000?
Keep it short and to the point. 1.02. What is the ratio of the Female students (as % of total students) in Tertiary education in 1999 to that in 2000?
Your answer should be very brief. 1.01. What is the ratio of the Female students (as % of total students) in Secondary general education in 1999 to that in 2000?
Ensure brevity in your answer.  1.04. What is the ratio of the Female students (as % of total students) of Secondary vocational education in 1999 to that in 2000?
Keep it short and to the point. 1.1. What is the ratio of the Female students (as % of total students) of Primary education in 1999 to that in 2001?
Your answer should be compact. 1.03. What is the ratio of the Female students (as % of total students) in Tertiary education in 1999 to that in 2001?
Offer a very short reply. 1.01. What is the ratio of the Female students (as % of total students) in Secondary general education in 1999 to that in 2001?
Ensure brevity in your answer.  1.05. What is the ratio of the Female students (as % of total students) of Secondary vocational education in 1999 to that in 2001?
Offer a very short reply. 1.23. What is the ratio of the Female students (as % of total students) in Primary education in 1999 to that in 2002?
Provide a succinct answer. 1.03. What is the ratio of the Female students (as % of total students) of Tertiary education in 1999 to that in 2002?
Offer a terse response. 1.01. What is the ratio of the Female students (as % of total students) in Secondary general education in 1999 to that in 2002?
Ensure brevity in your answer.  1.07. What is the ratio of the Female students (as % of total students) of Secondary vocational education in 1999 to that in 2002?
Provide a succinct answer. 0.91. What is the ratio of the Female students (as % of total students) of Primary education in 2000 to that in 2001?
Provide a succinct answer. 1.01. What is the ratio of the Female students (as % of total students) in Tertiary education in 2000 to that in 2001?
Give a very brief answer. 1. What is the ratio of the Female students (as % of total students) of Secondary general education in 2000 to that in 2001?
Keep it short and to the point. 1.01. What is the ratio of the Female students (as % of total students) of Secondary vocational education in 2000 to that in 2001?
Your answer should be compact. 1.11. What is the ratio of the Female students (as % of total students) in Primary education in 2000 to that in 2002?
Keep it short and to the point. 1.01. What is the ratio of the Female students (as % of total students) of Secondary general education in 2000 to that in 2002?
Ensure brevity in your answer.  1.02. What is the ratio of the Female students (as % of total students) of Secondary vocational education in 2000 to that in 2002?
Your answer should be very brief. 0.83. What is the ratio of the Female students (as % of total students) in Primary education in 2001 to that in 2002?
Your answer should be compact. 1. What is the ratio of the Female students (as % of total students) of Tertiary education in 2001 to that in 2002?
Offer a terse response. 1. What is the ratio of the Female students (as % of total students) of Secondary general education in 2001 to that in 2002?
Keep it short and to the point. 1.01. What is the ratio of the Female students (as % of total students) in Secondary vocational education in 2001 to that in 2002?
Your answer should be compact. 0.74. What is the difference between the highest and the second highest Female students (as % of total students) of Primary education?
Give a very brief answer. 0.12. What is the difference between the highest and the second highest Female students (as % of total students) in Tertiary education?
Offer a terse response. 2.33. What is the difference between the highest and the second highest Female students (as % of total students) of Secondary general education?
Offer a very short reply. 1.04. What is the difference between the highest and the second highest Female students (as % of total students) in Secondary vocational education?
Keep it short and to the point. 2.91. What is the difference between the highest and the lowest Female students (as % of total students) of Primary education?
Ensure brevity in your answer.  1.83. What is the difference between the highest and the lowest Female students (as % of total students) in Tertiary education?
Provide a succinct answer. 3.79. What is the difference between the highest and the lowest Female students (as % of total students) in Secondary general education?
Offer a very short reply. 3.83. What is the difference between the highest and the lowest Female students (as % of total students) of Secondary vocational education?
Provide a short and direct response. 15.45. 